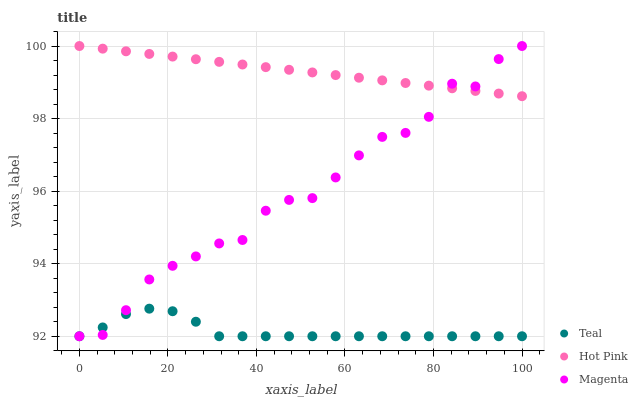Does Teal have the minimum area under the curve?
Answer yes or no. Yes. Does Hot Pink have the maximum area under the curve?
Answer yes or no. Yes. Does Hot Pink have the minimum area under the curve?
Answer yes or no. No. Does Teal have the maximum area under the curve?
Answer yes or no. No. Is Hot Pink the smoothest?
Answer yes or no. Yes. Is Magenta the roughest?
Answer yes or no. Yes. Is Teal the smoothest?
Answer yes or no. No. Is Teal the roughest?
Answer yes or no. No. Does Magenta have the lowest value?
Answer yes or no. Yes. Does Hot Pink have the lowest value?
Answer yes or no. No. Does Hot Pink have the highest value?
Answer yes or no. Yes. Does Teal have the highest value?
Answer yes or no. No. Is Teal less than Hot Pink?
Answer yes or no. Yes. Is Hot Pink greater than Teal?
Answer yes or no. Yes. Does Magenta intersect Hot Pink?
Answer yes or no. Yes. Is Magenta less than Hot Pink?
Answer yes or no. No. Is Magenta greater than Hot Pink?
Answer yes or no. No. Does Teal intersect Hot Pink?
Answer yes or no. No. 